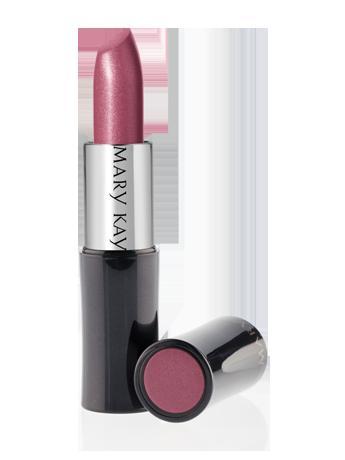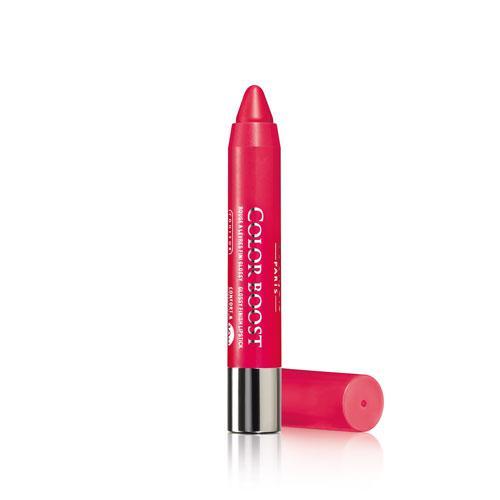The first image is the image on the left, the second image is the image on the right. Considering the images on both sides, is "Two lipsticks with the color extended stand beside the black cap of each tube." valid? Answer yes or no. No. The first image is the image on the left, the second image is the image on the right. Examine the images to the left and right. Is the description "Images show a total of two red lipsticks with black caps." accurate? Answer yes or no. No. 